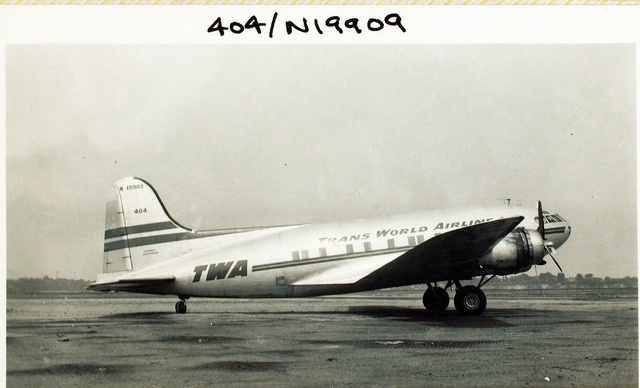Describe the objects in this image and their specific colors. I can see a airplane in beige, ivory, black, gray, and darkgray tones in this image. 